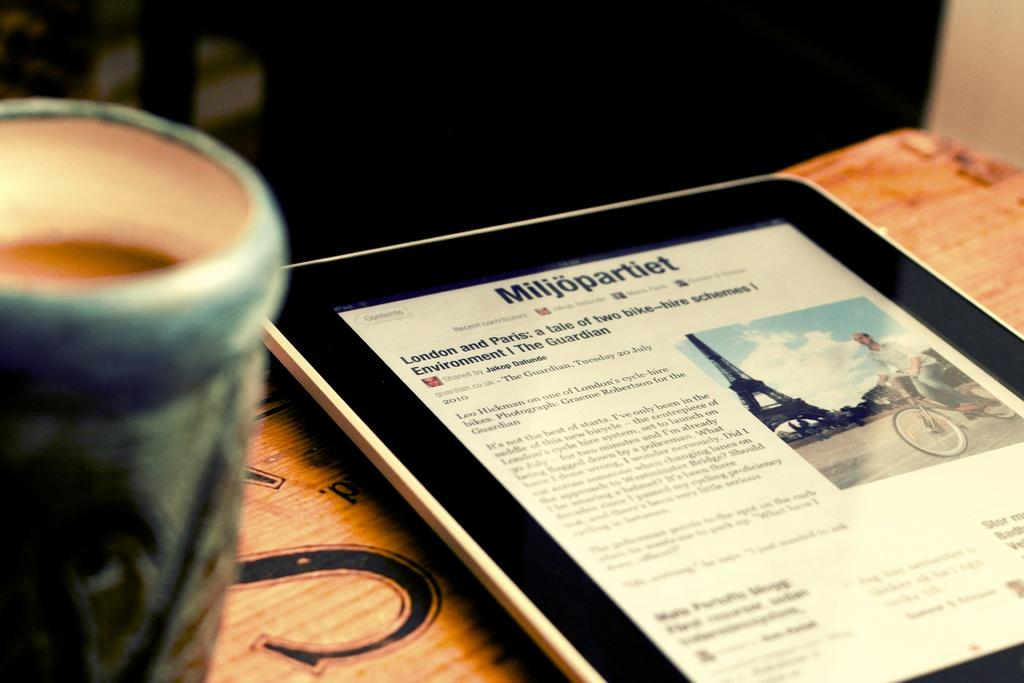<image>
Render a clear and concise summary of the photo. A e-tablet is used to read a newspaper article about London and Paris. 